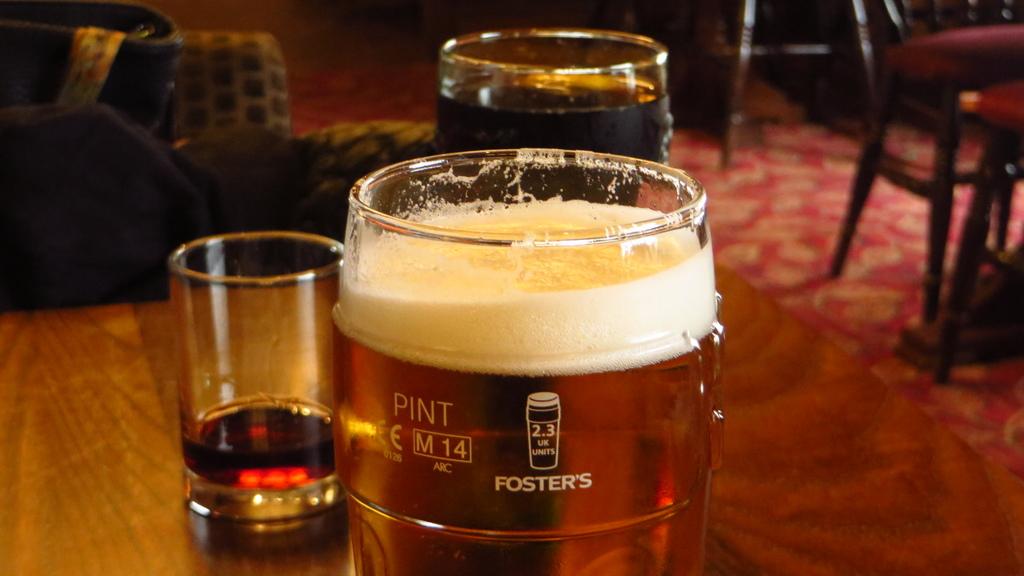What is the volume of this glass?
Your answer should be compact. Pint. What brand is on the glass?
Provide a succinct answer. Foster's. 